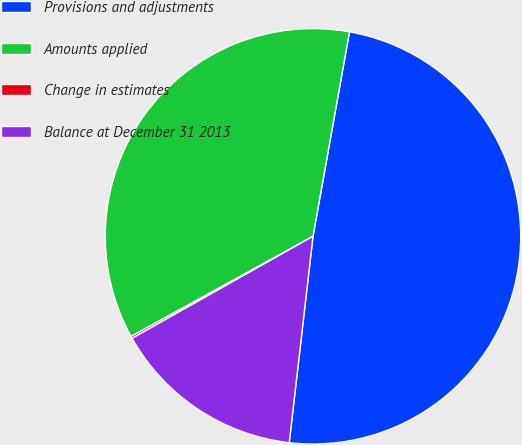Convert chart to OTSL. <chart><loc_0><loc_0><loc_500><loc_500><pie_chart><fcel>Provisions and adjustments<fcel>Amounts applied<fcel>Change in estimates<fcel>Balance at December 31 2013<nl><fcel>49.02%<fcel>35.82%<fcel>0.17%<fcel>15.0%<nl></chart> 